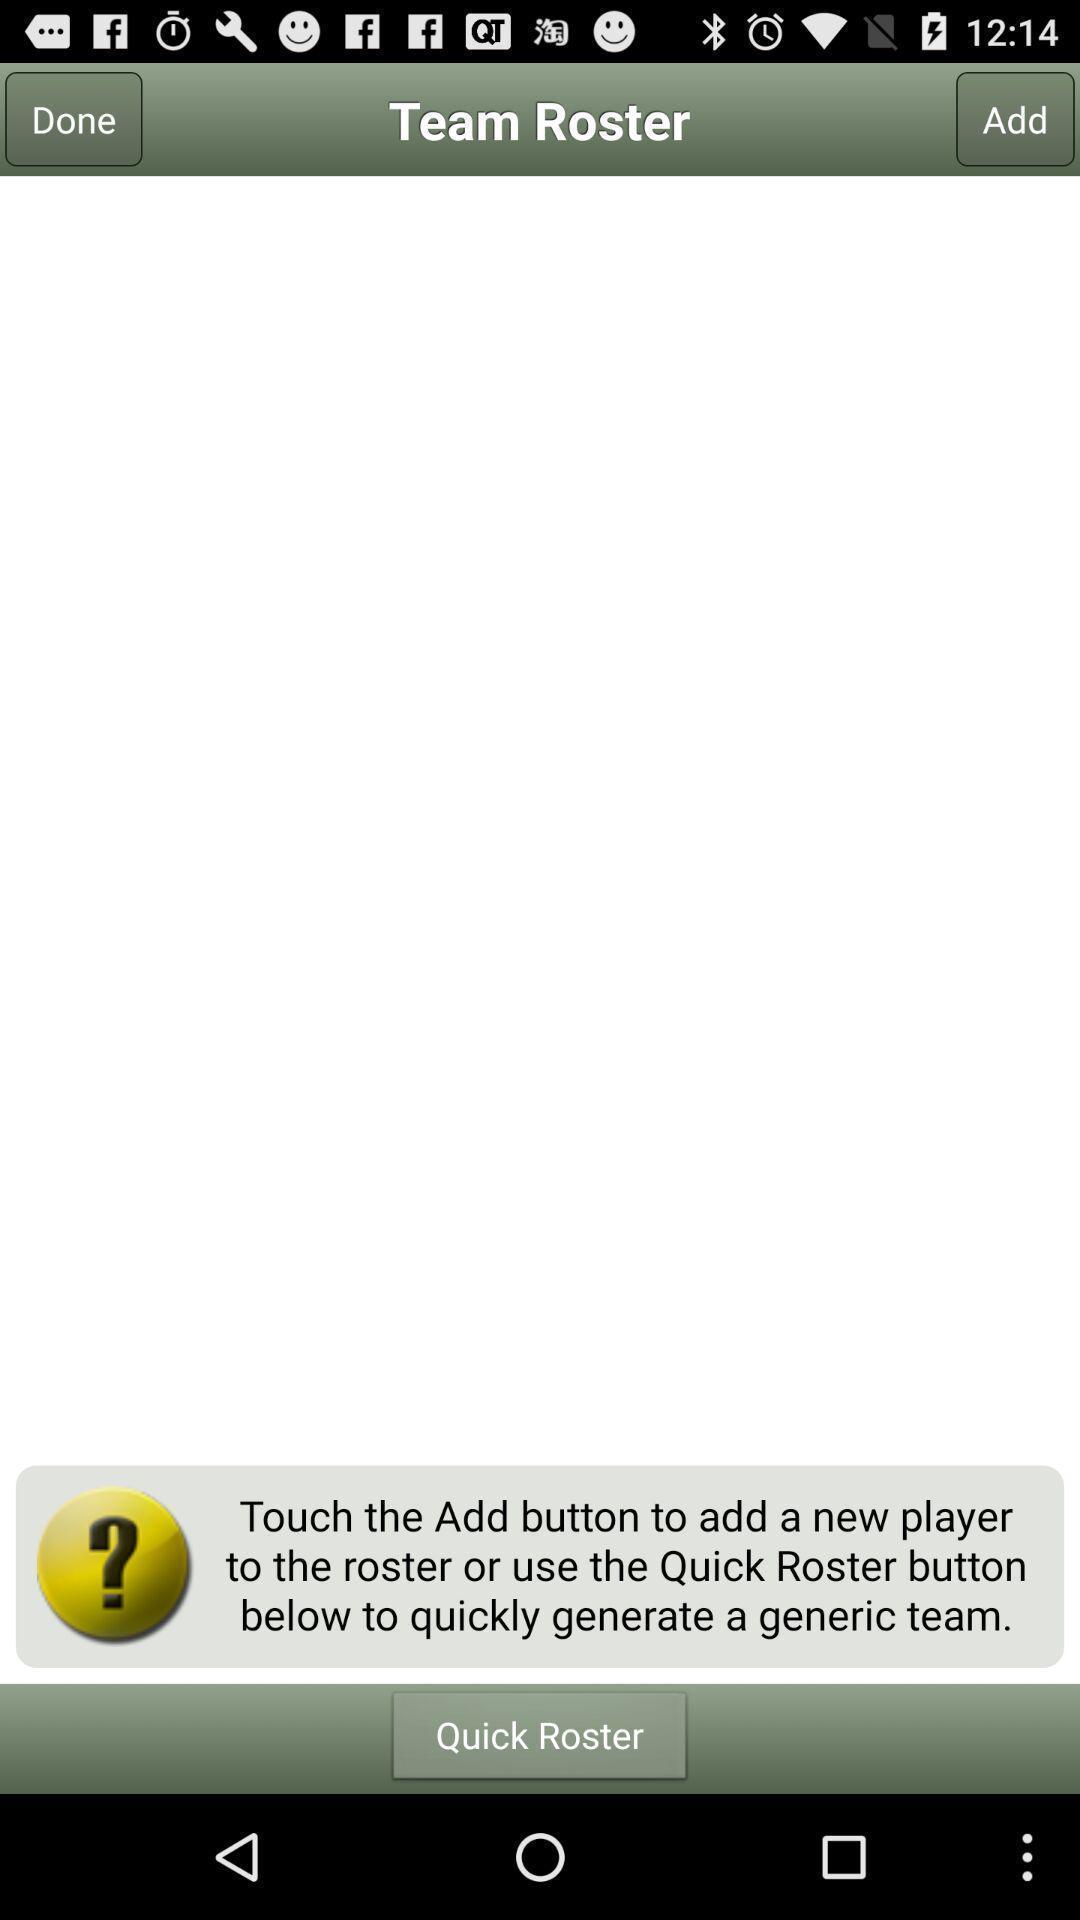Summarize the main components in this picture. Team roster page of a sports app. 